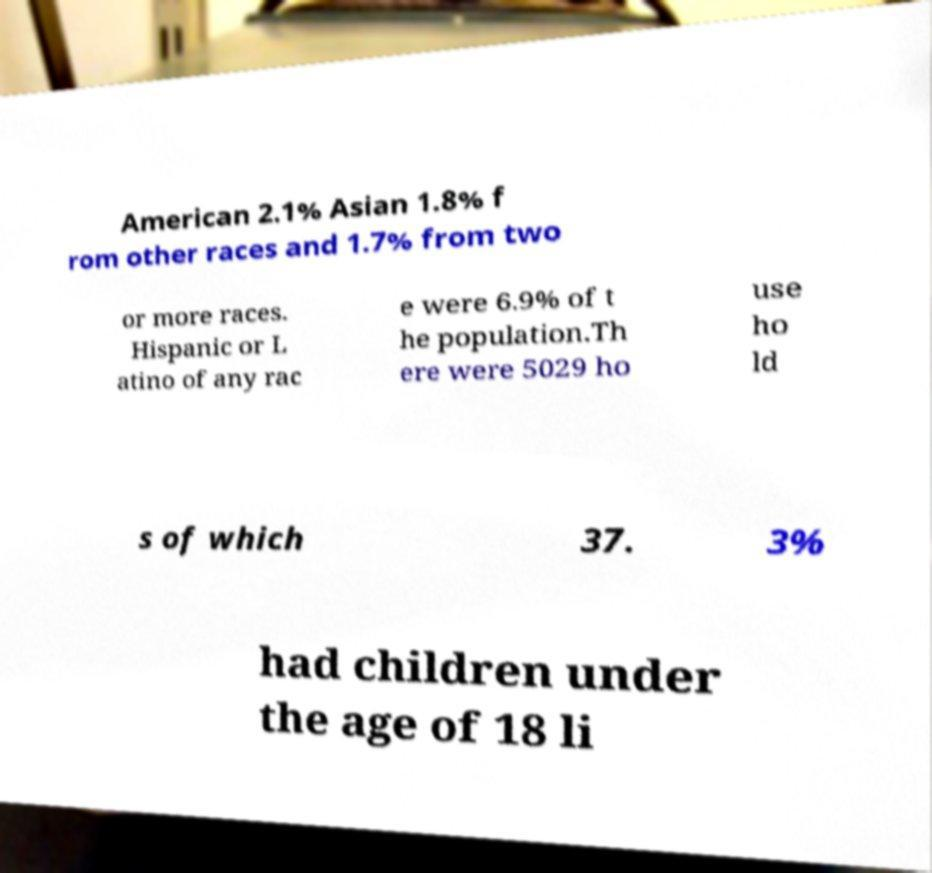Please identify and transcribe the text found in this image. American 2.1% Asian 1.8% f rom other races and 1.7% from two or more races. Hispanic or L atino of any rac e were 6.9% of t he population.Th ere were 5029 ho use ho ld s of which 37. 3% had children under the age of 18 li 